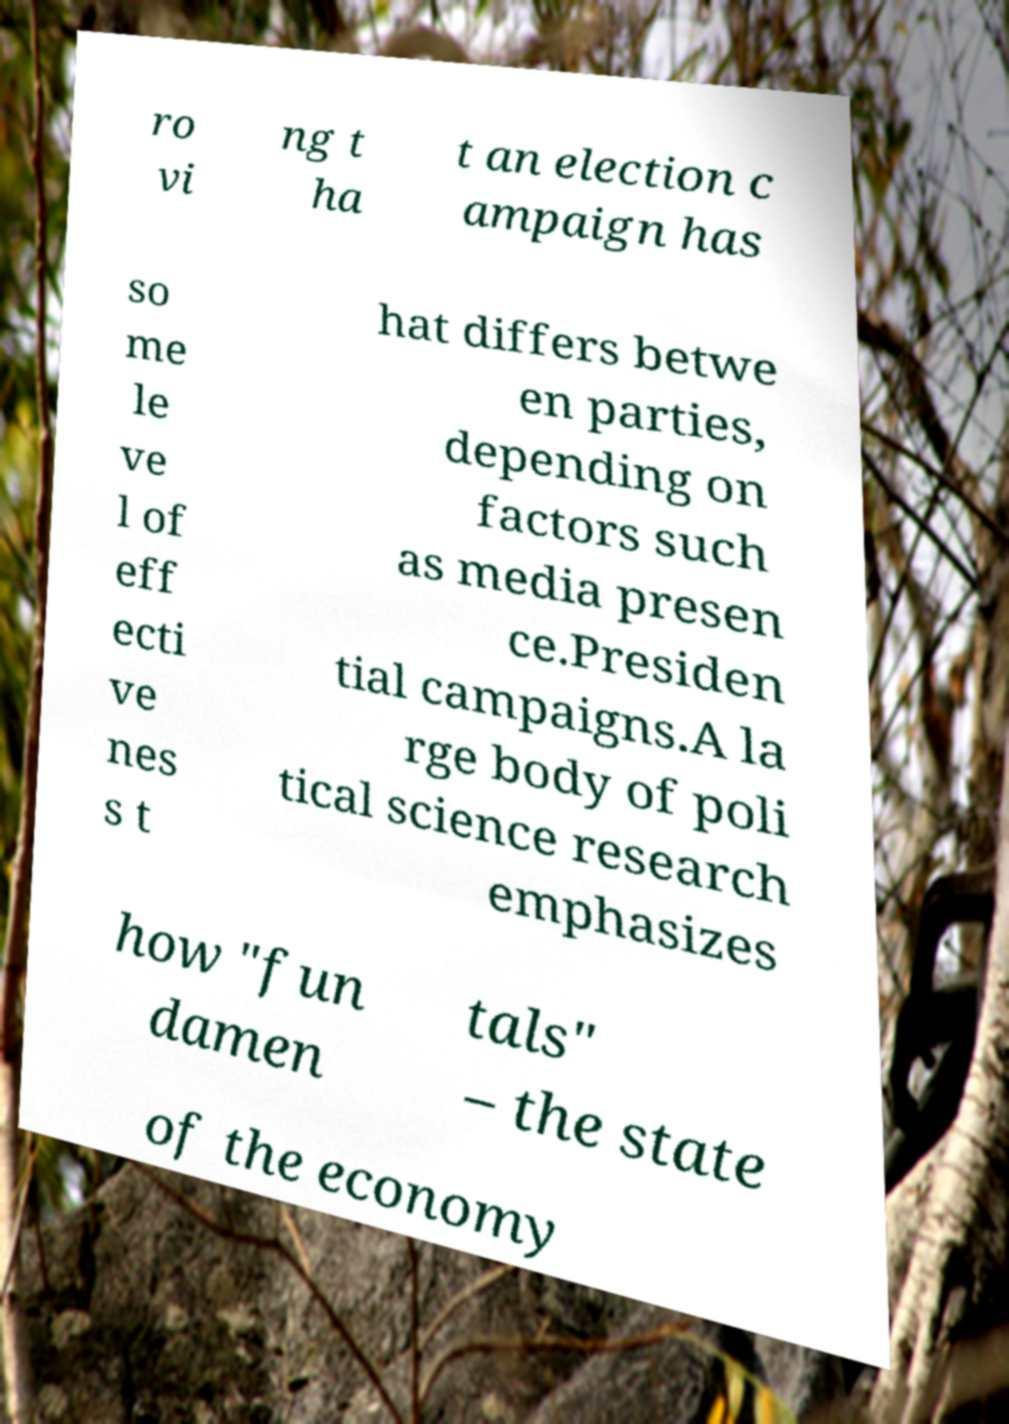There's text embedded in this image that I need extracted. Can you transcribe it verbatim? ro vi ng t ha t an election c ampaign has so me le ve l of eff ecti ve nes s t hat differs betwe en parties, depending on factors such as media presen ce.Presiden tial campaigns.A la rge body of poli tical science research emphasizes how "fun damen tals" – the state of the economy 